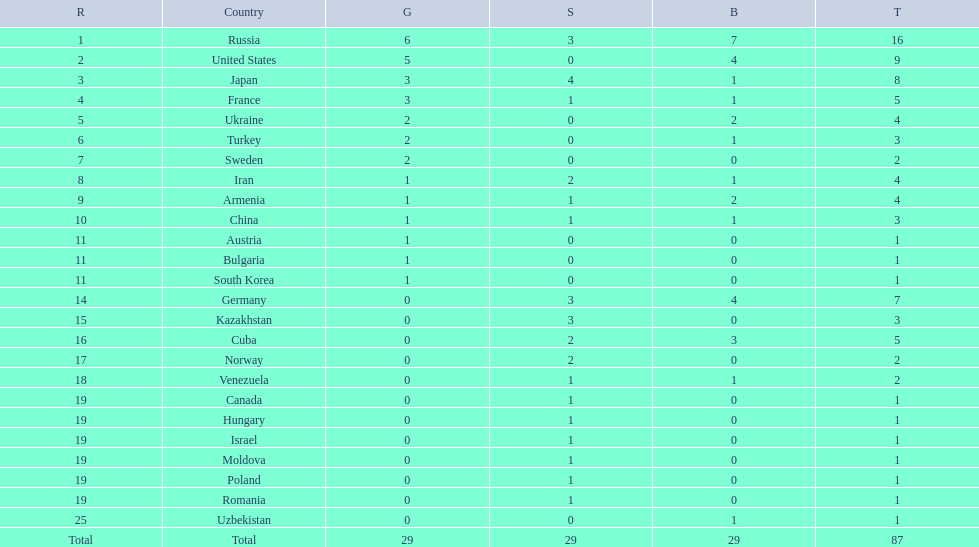How many gold medals did the united states win? 5. Who won more than 5 gold medals? Russia. Which nations have gold medals? Russia, United States, Japan, France, Ukraine, Turkey, Sweden, Iran, Armenia, China, Austria, Bulgaria, South Korea. Can you give me this table in json format? {'header': ['R', 'Country', 'G', 'S', 'B', 'T'], 'rows': [['1', 'Russia', '6', '3', '7', '16'], ['2', 'United States', '5', '0', '4', '9'], ['3', 'Japan', '3', '4', '1', '8'], ['4', 'France', '3', '1', '1', '5'], ['5', 'Ukraine', '2', '0', '2', '4'], ['6', 'Turkey', '2', '0', '1', '3'], ['7', 'Sweden', '2', '0', '0', '2'], ['8', 'Iran', '1', '2', '1', '4'], ['9', 'Armenia', '1', '1', '2', '4'], ['10', 'China', '1', '1', '1', '3'], ['11', 'Austria', '1', '0', '0', '1'], ['11', 'Bulgaria', '1', '0', '0', '1'], ['11', 'South Korea', '1', '0', '0', '1'], ['14', 'Germany', '0', '3', '4', '7'], ['15', 'Kazakhstan', '0', '3', '0', '3'], ['16', 'Cuba', '0', '2', '3', '5'], ['17', 'Norway', '0', '2', '0', '2'], ['18', 'Venezuela', '0', '1', '1', '2'], ['19', 'Canada', '0', '1', '0', '1'], ['19', 'Hungary', '0', '1', '0', '1'], ['19', 'Israel', '0', '1', '0', '1'], ['19', 'Moldova', '0', '1', '0', '1'], ['19', 'Poland', '0', '1', '0', '1'], ['19', 'Romania', '0', '1', '0', '1'], ['25', 'Uzbekistan', '0', '0', '1', '1'], ['Total', 'Total', '29', '29', '29', '87']]} Of those nations, which have only one gold medal? Iran, Armenia, China, Austria, Bulgaria, South Korea. Of those nations, which has no bronze or silver medals? Austria. 